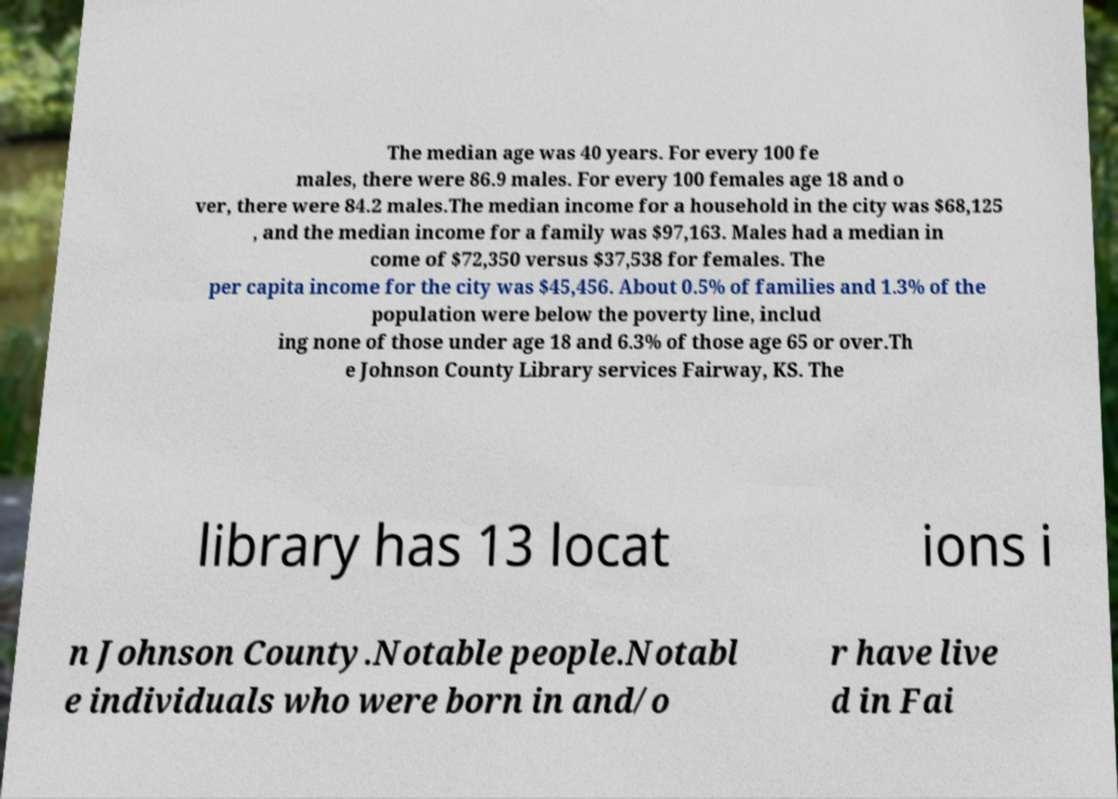Can you read and provide the text displayed in the image?This photo seems to have some interesting text. Can you extract and type it out for me? The median age was 40 years. For every 100 fe males, there were 86.9 males. For every 100 females age 18 and o ver, there were 84.2 males.The median income for a household in the city was $68,125 , and the median income for a family was $97,163. Males had a median in come of $72,350 versus $37,538 for females. The per capita income for the city was $45,456. About 0.5% of families and 1.3% of the population were below the poverty line, includ ing none of those under age 18 and 6.3% of those age 65 or over.Th e Johnson County Library services Fairway, KS. The library has 13 locat ions i n Johnson County.Notable people.Notabl e individuals who were born in and/o r have live d in Fai 